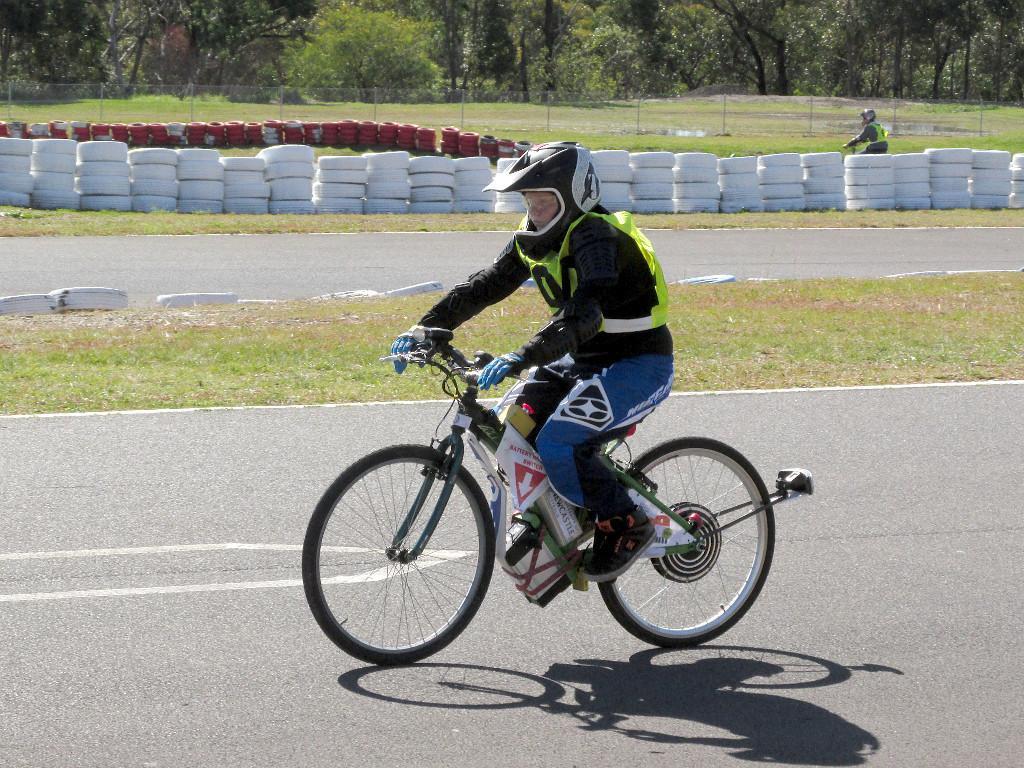Describe this image in one or two sentences. In the foreground of the picture we can see grass, tyres, road, bicycle and a person on it. In the middle of the picture we can see tyres, grass, person and fencing. In the background there are trees and grass 